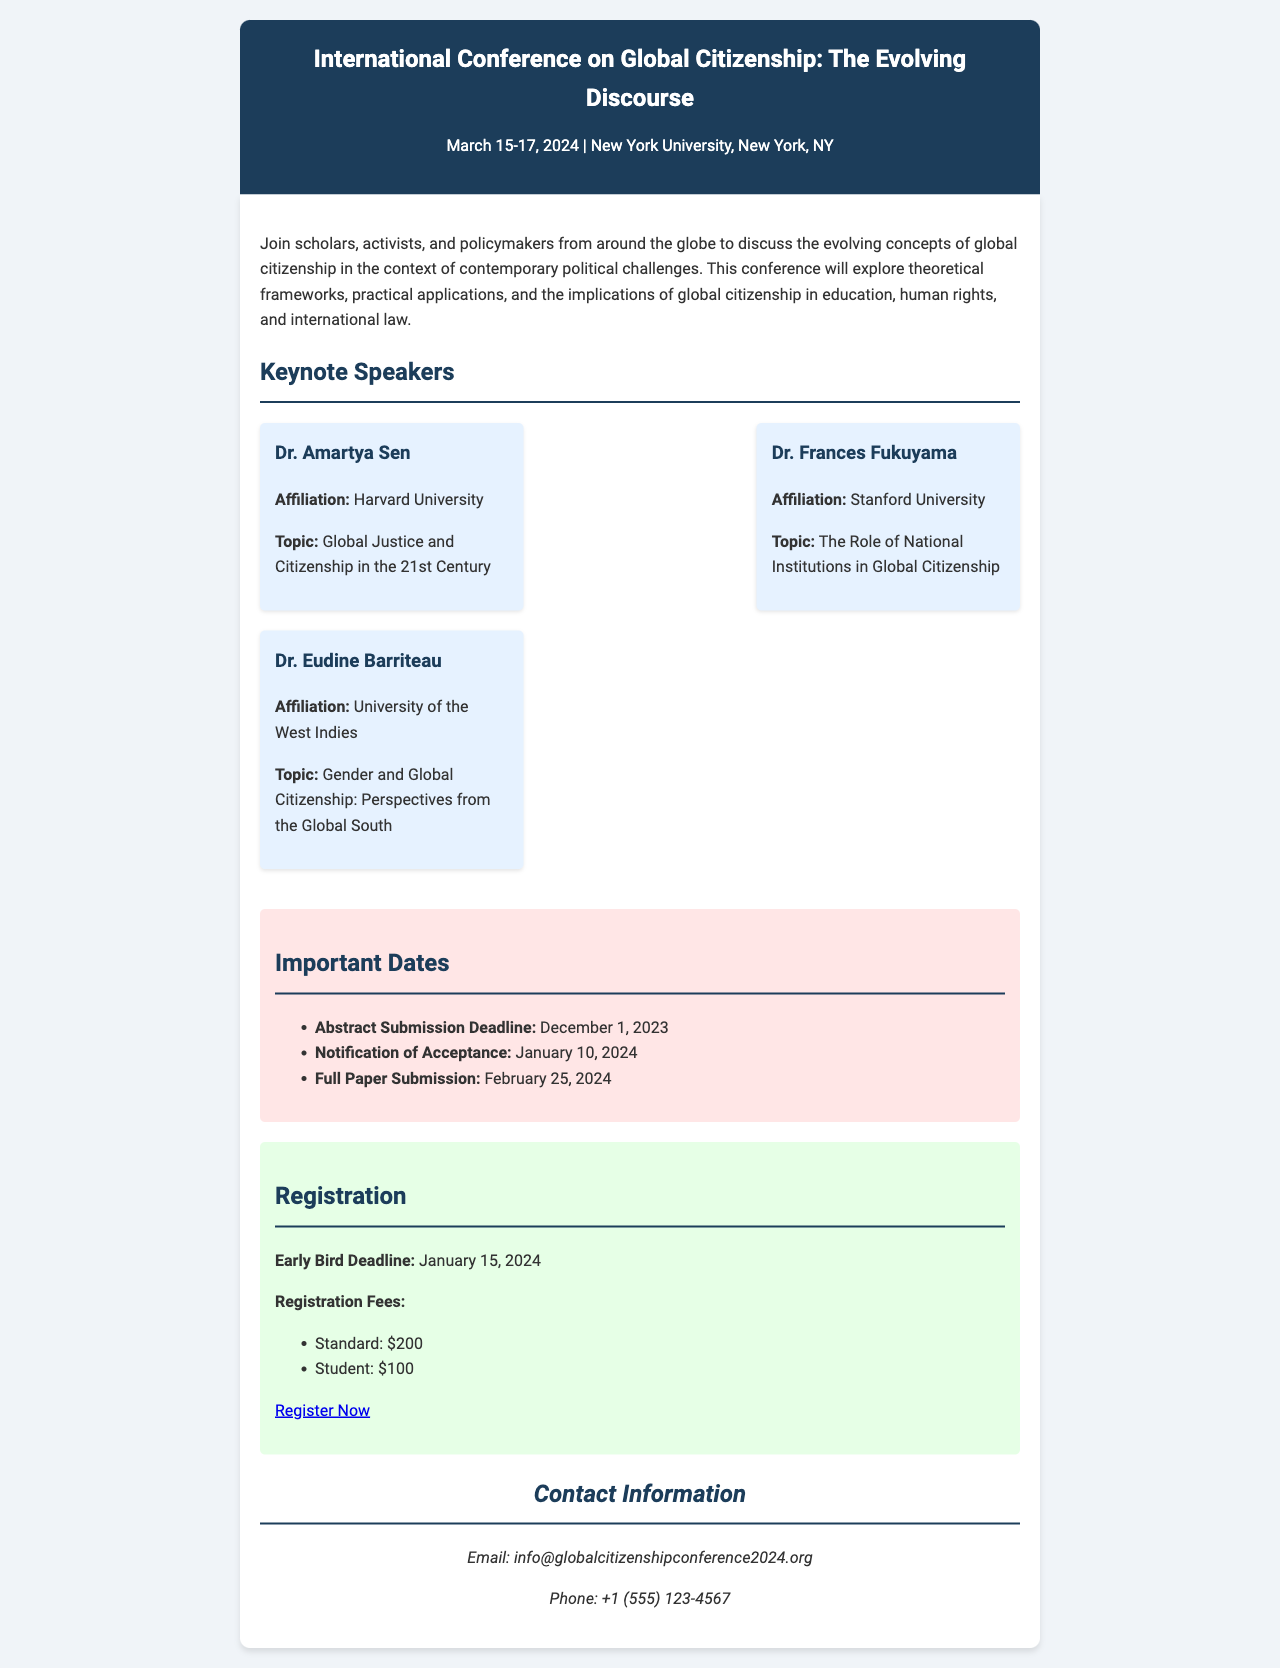What are the dates of the conference? The dates of the conference are clearly stated in the header of the document as March 15-17, 2024.
Answer: March 15-17, 2024 Who is the keynote speaker from Harvard University? The document lists Dr. Amartya Sen as the keynote speaker affiliated with Harvard University in the keynote speakers section.
Answer: Dr. Amartya Sen What is the registration fee for students? The document specifies the registration fee for students in the registration section as $100.
Answer: $100 When is the abstract submission deadline? The abstract submission deadline is mentioned in the important dates section of the document as December 1, 2023.
Answer: December 1, 2023 What topic will Dr. Eudine Barriteau discuss? The document provides Dr. Eudine Barriteau's topic in the keynote speakers section as "Gender and Global Citizenship: Perspectives from the Global South."
Answer: Gender and Global Citizenship: Perspectives from the Global South By how many days does the early bird registration deadline precede the conference dates? The early bird registration deadline is January 15, 2024, and the conference begins on March 15, 2024; therefore, the number of days is calculated as 59 days.
Answer: 59 days What is the phone number provided for contact? The document includes a contact section that lists the phone number as +1 (555) 123-4567.
Answer: +1 (555) 123-4567 What action should one take to register for the conference? The document encourages readers to register by visiting a specific link provided for registration, found in the registration section.
Answer: Register Now 